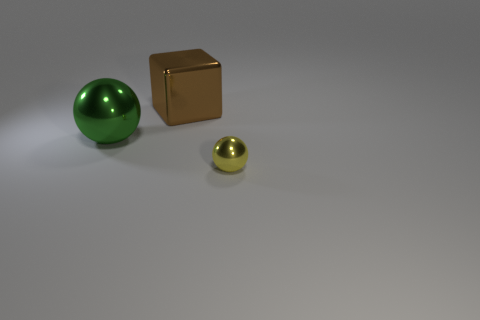Subtract all spheres. How many objects are left? 1 Add 2 big yellow cylinders. How many objects exist? 5 Subtract all big green spheres. Subtract all small yellow metallic objects. How many objects are left? 1 Add 2 big green metal spheres. How many big green metal spheres are left? 3 Add 3 big metal things. How many big metal things exist? 5 Subtract 0 green cubes. How many objects are left? 3 